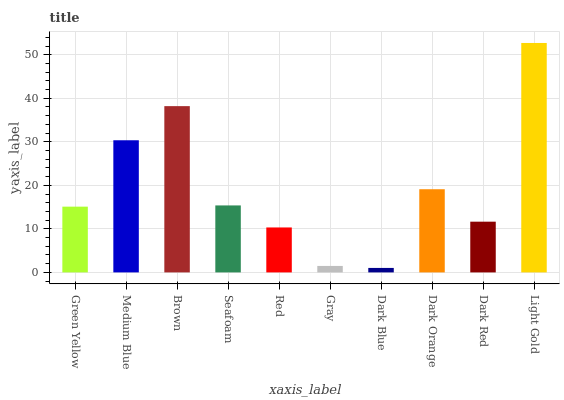Is Medium Blue the minimum?
Answer yes or no. No. Is Medium Blue the maximum?
Answer yes or no. No. Is Medium Blue greater than Green Yellow?
Answer yes or no. Yes. Is Green Yellow less than Medium Blue?
Answer yes or no. Yes. Is Green Yellow greater than Medium Blue?
Answer yes or no. No. Is Medium Blue less than Green Yellow?
Answer yes or no. No. Is Seafoam the high median?
Answer yes or no. Yes. Is Green Yellow the low median?
Answer yes or no. Yes. Is Light Gold the high median?
Answer yes or no. No. Is Dark Blue the low median?
Answer yes or no. No. 